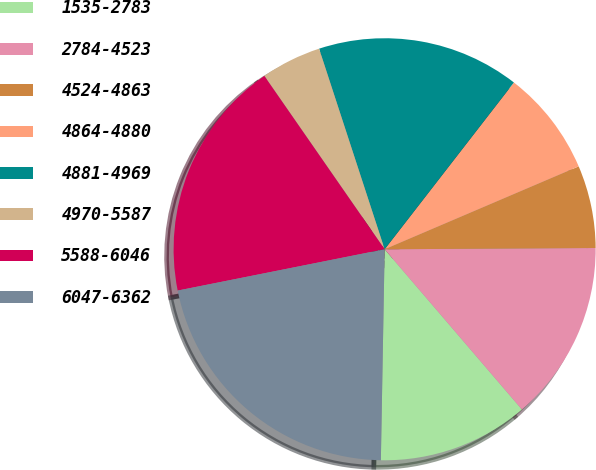<chart> <loc_0><loc_0><loc_500><loc_500><pie_chart><fcel>1535-2783<fcel>2784-4523<fcel>4524-4863<fcel>4864-4880<fcel>4881-4969<fcel>4970-5587<fcel>5588-6046<fcel>6047-6362<nl><fcel>11.56%<fcel>13.82%<fcel>6.33%<fcel>8.08%<fcel>15.52%<fcel>4.63%<fcel>18.48%<fcel>21.58%<nl></chart> 